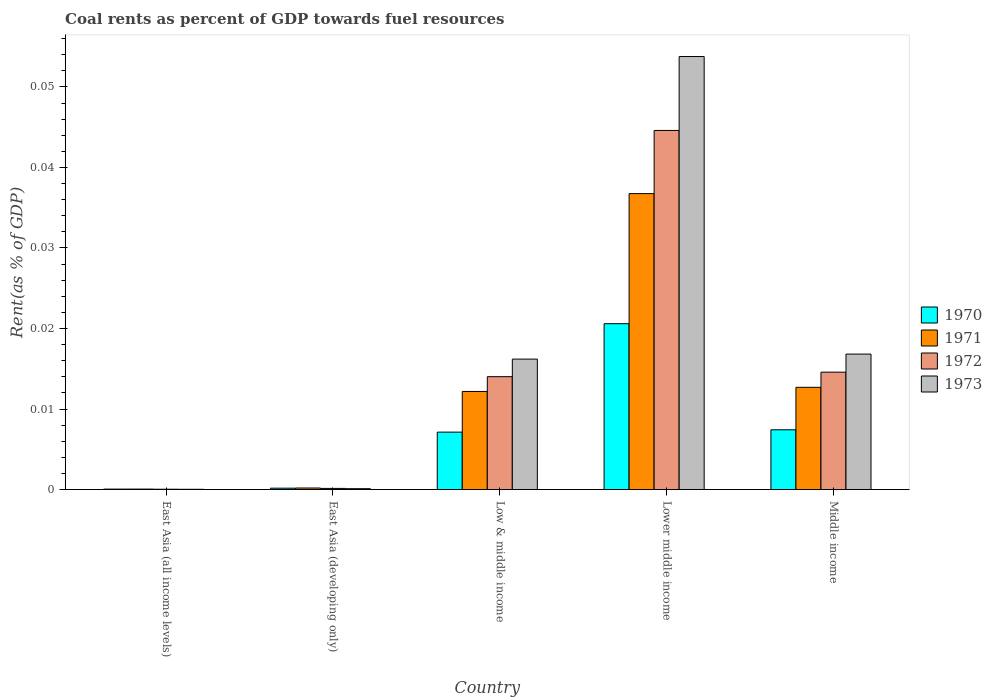How many groups of bars are there?
Your answer should be very brief. 5. Are the number of bars per tick equal to the number of legend labels?
Offer a very short reply. Yes. Are the number of bars on each tick of the X-axis equal?
Your answer should be very brief. Yes. What is the label of the 5th group of bars from the left?
Your answer should be compact. Middle income. What is the coal rent in 1973 in Middle income?
Offer a very short reply. 0.02. Across all countries, what is the maximum coal rent in 1971?
Offer a terse response. 0.04. Across all countries, what is the minimum coal rent in 1971?
Your answer should be very brief. 5.470114168356261e-5. In which country was the coal rent in 1973 maximum?
Your response must be concise. Lower middle income. In which country was the coal rent in 1970 minimum?
Make the answer very short. East Asia (all income levels). What is the total coal rent in 1973 in the graph?
Give a very brief answer. 0.09. What is the difference between the coal rent in 1970 in Lower middle income and that in Middle income?
Offer a very short reply. 0.01. What is the difference between the coal rent in 1973 in Middle income and the coal rent in 1970 in Lower middle income?
Your response must be concise. -0. What is the average coal rent in 1972 per country?
Ensure brevity in your answer.  0.01. What is the difference between the coal rent of/in 1973 and coal rent of/in 1971 in East Asia (all income levels)?
Your response must be concise. -2.828401691496121e-5. What is the ratio of the coal rent in 1971 in East Asia (all income levels) to that in Lower middle income?
Keep it short and to the point. 0. Is the difference between the coal rent in 1973 in East Asia (all income levels) and Lower middle income greater than the difference between the coal rent in 1971 in East Asia (all income levels) and Lower middle income?
Keep it short and to the point. No. What is the difference between the highest and the second highest coal rent in 1972?
Offer a terse response. 0.03. What is the difference between the highest and the lowest coal rent in 1972?
Give a very brief answer. 0.04. In how many countries, is the coal rent in 1973 greater than the average coal rent in 1973 taken over all countries?
Ensure brevity in your answer.  1. Is the sum of the coal rent in 1973 in Lower middle income and Middle income greater than the maximum coal rent in 1972 across all countries?
Offer a terse response. Yes. Is it the case that in every country, the sum of the coal rent in 1970 and coal rent in 1973 is greater than the sum of coal rent in 1972 and coal rent in 1971?
Your answer should be very brief. No. Is it the case that in every country, the sum of the coal rent in 1970 and coal rent in 1972 is greater than the coal rent in 1971?
Ensure brevity in your answer.  Yes. How many bars are there?
Your answer should be compact. 20. Are all the bars in the graph horizontal?
Provide a short and direct response. No. What is the difference between two consecutive major ticks on the Y-axis?
Keep it short and to the point. 0.01. Does the graph contain grids?
Offer a very short reply. No. How many legend labels are there?
Offer a terse response. 4. How are the legend labels stacked?
Make the answer very short. Vertical. What is the title of the graph?
Your answer should be very brief. Coal rents as percent of GDP towards fuel resources. What is the label or title of the X-axis?
Your answer should be compact. Country. What is the label or title of the Y-axis?
Provide a succinct answer. Rent(as % of GDP). What is the Rent(as % of GDP) of 1970 in East Asia (all income levels)?
Make the answer very short. 5.1314079013758e-5. What is the Rent(as % of GDP) in 1971 in East Asia (all income levels)?
Ensure brevity in your answer.  5.470114168356261e-5. What is the Rent(as % of GDP) of 1972 in East Asia (all income levels)?
Offer a terse response. 3.67730514806032e-5. What is the Rent(as % of GDP) of 1973 in East Asia (all income levels)?
Ensure brevity in your answer.  2.64171247686014e-5. What is the Rent(as % of GDP) in 1970 in East Asia (developing only)?
Provide a short and direct response. 0. What is the Rent(as % of GDP) of 1971 in East Asia (developing only)?
Give a very brief answer. 0. What is the Rent(as % of GDP) of 1972 in East Asia (developing only)?
Provide a succinct answer. 0. What is the Rent(as % of GDP) of 1973 in East Asia (developing only)?
Keep it short and to the point. 0. What is the Rent(as % of GDP) in 1970 in Low & middle income?
Offer a very short reply. 0.01. What is the Rent(as % of GDP) of 1971 in Low & middle income?
Make the answer very short. 0.01. What is the Rent(as % of GDP) in 1972 in Low & middle income?
Your answer should be very brief. 0.01. What is the Rent(as % of GDP) in 1973 in Low & middle income?
Ensure brevity in your answer.  0.02. What is the Rent(as % of GDP) of 1970 in Lower middle income?
Your response must be concise. 0.02. What is the Rent(as % of GDP) of 1971 in Lower middle income?
Your response must be concise. 0.04. What is the Rent(as % of GDP) of 1972 in Lower middle income?
Your answer should be compact. 0.04. What is the Rent(as % of GDP) in 1973 in Lower middle income?
Your response must be concise. 0.05. What is the Rent(as % of GDP) of 1970 in Middle income?
Keep it short and to the point. 0.01. What is the Rent(as % of GDP) in 1971 in Middle income?
Your answer should be compact. 0.01. What is the Rent(as % of GDP) of 1972 in Middle income?
Give a very brief answer. 0.01. What is the Rent(as % of GDP) of 1973 in Middle income?
Provide a short and direct response. 0.02. Across all countries, what is the maximum Rent(as % of GDP) of 1970?
Your response must be concise. 0.02. Across all countries, what is the maximum Rent(as % of GDP) of 1971?
Give a very brief answer. 0.04. Across all countries, what is the maximum Rent(as % of GDP) in 1972?
Offer a terse response. 0.04. Across all countries, what is the maximum Rent(as % of GDP) in 1973?
Give a very brief answer. 0.05. Across all countries, what is the minimum Rent(as % of GDP) in 1970?
Offer a terse response. 5.1314079013758e-5. Across all countries, what is the minimum Rent(as % of GDP) of 1971?
Offer a terse response. 5.470114168356261e-5. Across all countries, what is the minimum Rent(as % of GDP) in 1972?
Offer a terse response. 3.67730514806032e-5. Across all countries, what is the minimum Rent(as % of GDP) in 1973?
Give a very brief answer. 2.64171247686014e-5. What is the total Rent(as % of GDP) in 1970 in the graph?
Your response must be concise. 0.04. What is the total Rent(as % of GDP) in 1971 in the graph?
Make the answer very short. 0.06. What is the total Rent(as % of GDP) of 1972 in the graph?
Your response must be concise. 0.07. What is the total Rent(as % of GDP) of 1973 in the graph?
Keep it short and to the point. 0.09. What is the difference between the Rent(as % of GDP) in 1970 in East Asia (all income levels) and that in East Asia (developing only)?
Make the answer very short. -0. What is the difference between the Rent(as % of GDP) in 1971 in East Asia (all income levels) and that in East Asia (developing only)?
Give a very brief answer. -0. What is the difference between the Rent(as % of GDP) of 1972 in East Asia (all income levels) and that in East Asia (developing only)?
Give a very brief answer. -0. What is the difference between the Rent(as % of GDP) of 1973 in East Asia (all income levels) and that in East Asia (developing only)?
Offer a very short reply. -0. What is the difference between the Rent(as % of GDP) in 1970 in East Asia (all income levels) and that in Low & middle income?
Make the answer very short. -0.01. What is the difference between the Rent(as % of GDP) in 1971 in East Asia (all income levels) and that in Low & middle income?
Offer a terse response. -0.01. What is the difference between the Rent(as % of GDP) in 1972 in East Asia (all income levels) and that in Low & middle income?
Make the answer very short. -0.01. What is the difference between the Rent(as % of GDP) of 1973 in East Asia (all income levels) and that in Low & middle income?
Your answer should be very brief. -0.02. What is the difference between the Rent(as % of GDP) of 1970 in East Asia (all income levels) and that in Lower middle income?
Keep it short and to the point. -0.02. What is the difference between the Rent(as % of GDP) of 1971 in East Asia (all income levels) and that in Lower middle income?
Offer a terse response. -0.04. What is the difference between the Rent(as % of GDP) in 1972 in East Asia (all income levels) and that in Lower middle income?
Offer a very short reply. -0.04. What is the difference between the Rent(as % of GDP) of 1973 in East Asia (all income levels) and that in Lower middle income?
Give a very brief answer. -0.05. What is the difference between the Rent(as % of GDP) in 1970 in East Asia (all income levels) and that in Middle income?
Your answer should be very brief. -0.01. What is the difference between the Rent(as % of GDP) of 1971 in East Asia (all income levels) and that in Middle income?
Offer a very short reply. -0.01. What is the difference between the Rent(as % of GDP) of 1972 in East Asia (all income levels) and that in Middle income?
Your answer should be very brief. -0.01. What is the difference between the Rent(as % of GDP) of 1973 in East Asia (all income levels) and that in Middle income?
Give a very brief answer. -0.02. What is the difference between the Rent(as % of GDP) in 1970 in East Asia (developing only) and that in Low & middle income?
Your response must be concise. -0.01. What is the difference between the Rent(as % of GDP) in 1971 in East Asia (developing only) and that in Low & middle income?
Your answer should be very brief. -0.01. What is the difference between the Rent(as % of GDP) in 1972 in East Asia (developing only) and that in Low & middle income?
Your response must be concise. -0.01. What is the difference between the Rent(as % of GDP) of 1973 in East Asia (developing only) and that in Low & middle income?
Keep it short and to the point. -0.02. What is the difference between the Rent(as % of GDP) in 1970 in East Asia (developing only) and that in Lower middle income?
Your response must be concise. -0.02. What is the difference between the Rent(as % of GDP) of 1971 in East Asia (developing only) and that in Lower middle income?
Provide a succinct answer. -0.04. What is the difference between the Rent(as % of GDP) of 1972 in East Asia (developing only) and that in Lower middle income?
Make the answer very short. -0.04. What is the difference between the Rent(as % of GDP) in 1973 in East Asia (developing only) and that in Lower middle income?
Give a very brief answer. -0.05. What is the difference between the Rent(as % of GDP) in 1970 in East Asia (developing only) and that in Middle income?
Provide a succinct answer. -0.01. What is the difference between the Rent(as % of GDP) in 1971 in East Asia (developing only) and that in Middle income?
Your answer should be very brief. -0.01. What is the difference between the Rent(as % of GDP) of 1972 in East Asia (developing only) and that in Middle income?
Give a very brief answer. -0.01. What is the difference between the Rent(as % of GDP) of 1973 in East Asia (developing only) and that in Middle income?
Offer a terse response. -0.02. What is the difference between the Rent(as % of GDP) in 1970 in Low & middle income and that in Lower middle income?
Your answer should be very brief. -0.01. What is the difference between the Rent(as % of GDP) of 1971 in Low & middle income and that in Lower middle income?
Provide a short and direct response. -0.02. What is the difference between the Rent(as % of GDP) in 1972 in Low & middle income and that in Lower middle income?
Your answer should be compact. -0.03. What is the difference between the Rent(as % of GDP) of 1973 in Low & middle income and that in Lower middle income?
Make the answer very short. -0.04. What is the difference between the Rent(as % of GDP) of 1970 in Low & middle income and that in Middle income?
Provide a short and direct response. -0. What is the difference between the Rent(as % of GDP) of 1971 in Low & middle income and that in Middle income?
Your answer should be compact. -0. What is the difference between the Rent(as % of GDP) of 1972 in Low & middle income and that in Middle income?
Your answer should be very brief. -0. What is the difference between the Rent(as % of GDP) of 1973 in Low & middle income and that in Middle income?
Keep it short and to the point. -0. What is the difference between the Rent(as % of GDP) in 1970 in Lower middle income and that in Middle income?
Offer a terse response. 0.01. What is the difference between the Rent(as % of GDP) in 1971 in Lower middle income and that in Middle income?
Provide a short and direct response. 0.02. What is the difference between the Rent(as % of GDP) in 1973 in Lower middle income and that in Middle income?
Give a very brief answer. 0.04. What is the difference between the Rent(as % of GDP) of 1970 in East Asia (all income levels) and the Rent(as % of GDP) of 1971 in East Asia (developing only)?
Give a very brief answer. -0. What is the difference between the Rent(as % of GDP) in 1970 in East Asia (all income levels) and the Rent(as % of GDP) in 1972 in East Asia (developing only)?
Provide a short and direct response. -0. What is the difference between the Rent(as % of GDP) in 1970 in East Asia (all income levels) and the Rent(as % of GDP) in 1973 in East Asia (developing only)?
Offer a terse response. -0. What is the difference between the Rent(as % of GDP) in 1971 in East Asia (all income levels) and the Rent(as % of GDP) in 1972 in East Asia (developing only)?
Ensure brevity in your answer.  -0. What is the difference between the Rent(as % of GDP) of 1972 in East Asia (all income levels) and the Rent(as % of GDP) of 1973 in East Asia (developing only)?
Give a very brief answer. -0. What is the difference between the Rent(as % of GDP) of 1970 in East Asia (all income levels) and the Rent(as % of GDP) of 1971 in Low & middle income?
Your answer should be very brief. -0.01. What is the difference between the Rent(as % of GDP) of 1970 in East Asia (all income levels) and the Rent(as % of GDP) of 1972 in Low & middle income?
Your answer should be very brief. -0.01. What is the difference between the Rent(as % of GDP) in 1970 in East Asia (all income levels) and the Rent(as % of GDP) in 1973 in Low & middle income?
Provide a succinct answer. -0.02. What is the difference between the Rent(as % of GDP) of 1971 in East Asia (all income levels) and the Rent(as % of GDP) of 1972 in Low & middle income?
Your answer should be very brief. -0.01. What is the difference between the Rent(as % of GDP) of 1971 in East Asia (all income levels) and the Rent(as % of GDP) of 1973 in Low & middle income?
Provide a succinct answer. -0.02. What is the difference between the Rent(as % of GDP) of 1972 in East Asia (all income levels) and the Rent(as % of GDP) of 1973 in Low & middle income?
Your response must be concise. -0.02. What is the difference between the Rent(as % of GDP) of 1970 in East Asia (all income levels) and the Rent(as % of GDP) of 1971 in Lower middle income?
Offer a very short reply. -0.04. What is the difference between the Rent(as % of GDP) of 1970 in East Asia (all income levels) and the Rent(as % of GDP) of 1972 in Lower middle income?
Offer a terse response. -0.04. What is the difference between the Rent(as % of GDP) of 1970 in East Asia (all income levels) and the Rent(as % of GDP) of 1973 in Lower middle income?
Provide a succinct answer. -0.05. What is the difference between the Rent(as % of GDP) in 1971 in East Asia (all income levels) and the Rent(as % of GDP) in 1972 in Lower middle income?
Your response must be concise. -0.04. What is the difference between the Rent(as % of GDP) in 1971 in East Asia (all income levels) and the Rent(as % of GDP) in 1973 in Lower middle income?
Keep it short and to the point. -0.05. What is the difference between the Rent(as % of GDP) in 1972 in East Asia (all income levels) and the Rent(as % of GDP) in 1973 in Lower middle income?
Provide a succinct answer. -0.05. What is the difference between the Rent(as % of GDP) in 1970 in East Asia (all income levels) and the Rent(as % of GDP) in 1971 in Middle income?
Offer a terse response. -0.01. What is the difference between the Rent(as % of GDP) in 1970 in East Asia (all income levels) and the Rent(as % of GDP) in 1972 in Middle income?
Ensure brevity in your answer.  -0.01. What is the difference between the Rent(as % of GDP) in 1970 in East Asia (all income levels) and the Rent(as % of GDP) in 1973 in Middle income?
Offer a terse response. -0.02. What is the difference between the Rent(as % of GDP) of 1971 in East Asia (all income levels) and the Rent(as % of GDP) of 1972 in Middle income?
Your answer should be very brief. -0.01. What is the difference between the Rent(as % of GDP) of 1971 in East Asia (all income levels) and the Rent(as % of GDP) of 1973 in Middle income?
Provide a short and direct response. -0.02. What is the difference between the Rent(as % of GDP) of 1972 in East Asia (all income levels) and the Rent(as % of GDP) of 1973 in Middle income?
Offer a very short reply. -0.02. What is the difference between the Rent(as % of GDP) of 1970 in East Asia (developing only) and the Rent(as % of GDP) of 1971 in Low & middle income?
Offer a terse response. -0.01. What is the difference between the Rent(as % of GDP) of 1970 in East Asia (developing only) and the Rent(as % of GDP) of 1972 in Low & middle income?
Your answer should be very brief. -0.01. What is the difference between the Rent(as % of GDP) in 1970 in East Asia (developing only) and the Rent(as % of GDP) in 1973 in Low & middle income?
Provide a short and direct response. -0.02. What is the difference between the Rent(as % of GDP) in 1971 in East Asia (developing only) and the Rent(as % of GDP) in 1972 in Low & middle income?
Your response must be concise. -0.01. What is the difference between the Rent(as % of GDP) of 1971 in East Asia (developing only) and the Rent(as % of GDP) of 1973 in Low & middle income?
Offer a terse response. -0.02. What is the difference between the Rent(as % of GDP) of 1972 in East Asia (developing only) and the Rent(as % of GDP) of 1973 in Low & middle income?
Your response must be concise. -0.02. What is the difference between the Rent(as % of GDP) of 1970 in East Asia (developing only) and the Rent(as % of GDP) of 1971 in Lower middle income?
Offer a very short reply. -0.04. What is the difference between the Rent(as % of GDP) in 1970 in East Asia (developing only) and the Rent(as % of GDP) in 1972 in Lower middle income?
Make the answer very short. -0.04. What is the difference between the Rent(as % of GDP) of 1970 in East Asia (developing only) and the Rent(as % of GDP) of 1973 in Lower middle income?
Ensure brevity in your answer.  -0.05. What is the difference between the Rent(as % of GDP) of 1971 in East Asia (developing only) and the Rent(as % of GDP) of 1972 in Lower middle income?
Ensure brevity in your answer.  -0.04. What is the difference between the Rent(as % of GDP) in 1971 in East Asia (developing only) and the Rent(as % of GDP) in 1973 in Lower middle income?
Your answer should be compact. -0.05. What is the difference between the Rent(as % of GDP) of 1972 in East Asia (developing only) and the Rent(as % of GDP) of 1973 in Lower middle income?
Your answer should be compact. -0.05. What is the difference between the Rent(as % of GDP) in 1970 in East Asia (developing only) and the Rent(as % of GDP) in 1971 in Middle income?
Keep it short and to the point. -0.01. What is the difference between the Rent(as % of GDP) of 1970 in East Asia (developing only) and the Rent(as % of GDP) of 1972 in Middle income?
Keep it short and to the point. -0.01. What is the difference between the Rent(as % of GDP) in 1970 in East Asia (developing only) and the Rent(as % of GDP) in 1973 in Middle income?
Offer a terse response. -0.02. What is the difference between the Rent(as % of GDP) of 1971 in East Asia (developing only) and the Rent(as % of GDP) of 1972 in Middle income?
Your response must be concise. -0.01. What is the difference between the Rent(as % of GDP) of 1971 in East Asia (developing only) and the Rent(as % of GDP) of 1973 in Middle income?
Provide a short and direct response. -0.02. What is the difference between the Rent(as % of GDP) in 1972 in East Asia (developing only) and the Rent(as % of GDP) in 1973 in Middle income?
Your response must be concise. -0.02. What is the difference between the Rent(as % of GDP) in 1970 in Low & middle income and the Rent(as % of GDP) in 1971 in Lower middle income?
Keep it short and to the point. -0.03. What is the difference between the Rent(as % of GDP) of 1970 in Low & middle income and the Rent(as % of GDP) of 1972 in Lower middle income?
Ensure brevity in your answer.  -0.04. What is the difference between the Rent(as % of GDP) in 1970 in Low & middle income and the Rent(as % of GDP) in 1973 in Lower middle income?
Provide a succinct answer. -0.05. What is the difference between the Rent(as % of GDP) in 1971 in Low & middle income and the Rent(as % of GDP) in 1972 in Lower middle income?
Ensure brevity in your answer.  -0.03. What is the difference between the Rent(as % of GDP) of 1971 in Low & middle income and the Rent(as % of GDP) of 1973 in Lower middle income?
Make the answer very short. -0.04. What is the difference between the Rent(as % of GDP) of 1972 in Low & middle income and the Rent(as % of GDP) of 1973 in Lower middle income?
Provide a short and direct response. -0.04. What is the difference between the Rent(as % of GDP) in 1970 in Low & middle income and the Rent(as % of GDP) in 1971 in Middle income?
Provide a short and direct response. -0.01. What is the difference between the Rent(as % of GDP) of 1970 in Low & middle income and the Rent(as % of GDP) of 1972 in Middle income?
Your response must be concise. -0.01. What is the difference between the Rent(as % of GDP) in 1970 in Low & middle income and the Rent(as % of GDP) in 1973 in Middle income?
Provide a succinct answer. -0.01. What is the difference between the Rent(as % of GDP) in 1971 in Low & middle income and the Rent(as % of GDP) in 1972 in Middle income?
Give a very brief answer. -0. What is the difference between the Rent(as % of GDP) in 1971 in Low & middle income and the Rent(as % of GDP) in 1973 in Middle income?
Offer a terse response. -0. What is the difference between the Rent(as % of GDP) of 1972 in Low & middle income and the Rent(as % of GDP) of 1973 in Middle income?
Your answer should be compact. -0. What is the difference between the Rent(as % of GDP) in 1970 in Lower middle income and the Rent(as % of GDP) in 1971 in Middle income?
Keep it short and to the point. 0.01. What is the difference between the Rent(as % of GDP) of 1970 in Lower middle income and the Rent(as % of GDP) of 1972 in Middle income?
Your answer should be compact. 0.01. What is the difference between the Rent(as % of GDP) in 1970 in Lower middle income and the Rent(as % of GDP) in 1973 in Middle income?
Your response must be concise. 0. What is the difference between the Rent(as % of GDP) in 1971 in Lower middle income and the Rent(as % of GDP) in 1972 in Middle income?
Offer a very short reply. 0.02. What is the difference between the Rent(as % of GDP) in 1971 in Lower middle income and the Rent(as % of GDP) in 1973 in Middle income?
Your response must be concise. 0.02. What is the difference between the Rent(as % of GDP) in 1972 in Lower middle income and the Rent(as % of GDP) in 1973 in Middle income?
Offer a very short reply. 0.03. What is the average Rent(as % of GDP) of 1970 per country?
Your answer should be very brief. 0.01. What is the average Rent(as % of GDP) in 1971 per country?
Your response must be concise. 0.01. What is the average Rent(as % of GDP) of 1972 per country?
Offer a very short reply. 0.01. What is the average Rent(as % of GDP) of 1973 per country?
Offer a terse response. 0.02. What is the difference between the Rent(as % of GDP) of 1970 and Rent(as % of GDP) of 1971 in East Asia (all income levels)?
Offer a very short reply. -0. What is the difference between the Rent(as % of GDP) of 1972 and Rent(as % of GDP) of 1973 in East Asia (all income levels)?
Keep it short and to the point. 0. What is the difference between the Rent(as % of GDP) in 1970 and Rent(as % of GDP) in 1971 in East Asia (developing only)?
Your response must be concise. -0. What is the difference between the Rent(as % of GDP) in 1971 and Rent(as % of GDP) in 1973 in East Asia (developing only)?
Your answer should be very brief. 0. What is the difference between the Rent(as % of GDP) in 1970 and Rent(as % of GDP) in 1971 in Low & middle income?
Provide a short and direct response. -0.01. What is the difference between the Rent(as % of GDP) of 1970 and Rent(as % of GDP) of 1972 in Low & middle income?
Provide a succinct answer. -0.01. What is the difference between the Rent(as % of GDP) in 1970 and Rent(as % of GDP) in 1973 in Low & middle income?
Keep it short and to the point. -0.01. What is the difference between the Rent(as % of GDP) of 1971 and Rent(as % of GDP) of 1972 in Low & middle income?
Offer a terse response. -0. What is the difference between the Rent(as % of GDP) of 1971 and Rent(as % of GDP) of 1973 in Low & middle income?
Your answer should be compact. -0. What is the difference between the Rent(as % of GDP) in 1972 and Rent(as % of GDP) in 1973 in Low & middle income?
Provide a succinct answer. -0. What is the difference between the Rent(as % of GDP) of 1970 and Rent(as % of GDP) of 1971 in Lower middle income?
Ensure brevity in your answer.  -0.02. What is the difference between the Rent(as % of GDP) of 1970 and Rent(as % of GDP) of 1972 in Lower middle income?
Your answer should be compact. -0.02. What is the difference between the Rent(as % of GDP) of 1970 and Rent(as % of GDP) of 1973 in Lower middle income?
Offer a very short reply. -0.03. What is the difference between the Rent(as % of GDP) of 1971 and Rent(as % of GDP) of 1972 in Lower middle income?
Ensure brevity in your answer.  -0.01. What is the difference between the Rent(as % of GDP) of 1971 and Rent(as % of GDP) of 1973 in Lower middle income?
Your response must be concise. -0.02. What is the difference between the Rent(as % of GDP) in 1972 and Rent(as % of GDP) in 1973 in Lower middle income?
Your answer should be very brief. -0.01. What is the difference between the Rent(as % of GDP) of 1970 and Rent(as % of GDP) of 1971 in Middle income?
Make the answer very short. -0.01. What is the difference between the Rent(as % of GDP) of 1970 and Rent(as % of GDP) of 1972 in Middle income?
Your answer should be compact. -0.01. What is the difference between the Rent(as % of GDP) of 1970 and Rent(as % of GDP) of 1973 in Middle income?
Offer a very short reply. -0.01. What is the difference between the Rent(as % of GDP) of 1971 and Rent(as % of GDP) of 1972 in Middle income?
Keep it short and to the point. -0. What is the difference between the Rent(as % of GDP) of 1971 and Rent(as % of GDP) of 1973 in Middle income?
Provide a succinct answer. -0. What is the difference between the Rent(as % of GDP) in 1972 and Rent(as % of GDP) in 1973 in Middle income?
Your response must be concise. -0. What is the ratio of the Rent(as % of GDP) of 1970 in East Asia (all income levels) to that in East Asia (developing only)?
Your response must be concise. 0.31. What is the ratio of the Rent(as % of GDP) in 1971 in East Asia (all income levels) to that in East Asia (developing only)?
Offer a terse response. 0.29. What is the ratio of the Rent(as % of GDP) of 1972 in East Asia (all income levels) to that in East Asia (developing only)?
Offer a terse response. 0.27. What is the ratio of the Rent(as % of GDP) in 1973 in East Asia (all income levels) to that in East Asia (developing only)?
Offer a terse response. 0.26. What is the ratio of the Rent(as % of GDP) in 1970 in East Asia (all income levels) to that in Low & middle income?
Your response must be concise. 0.01. What is the ratio of the Rent(as % of GDP) of 1971 in East Asia (all income levels) to that in Low & middle income?
Your response must be concise. 0. What is the ratio of the Rent(as % of GDP) in 1972 in East Asia (all income levels) to that in Low & middle income?
Give a very brief answer. 0. What is the ratio of the Rent(as % of GDP) of 1973 in East Asia (all income levels) to that in Low & middle income?
Provide a succinct answer. 0. What is the ratio of the Rent(as % of GDP) in 1970 in East Asia (all income levels) to that in Lower middle income?
Keep it short and to the point. 0. What is the ratio of the Rent(as % of GDP) of 1971 in East Asia (all income levels) to that in Lower middle income?
Ensure brevity in your answer.  0. What is the ratio of the Rent(as % of GDP) in 1972 in East Asia (all income levels) to that in Lower middle income?
Ensure brevity in your answer.  0. What is the ratio of the Rent(as % of GDP) in 1970 in East Asia (all income levels) to that in Middle income?
Provide a succinct answer. 0.01. What is the ratio of the Rent(as % of GDP) of 1971 in East Asia (all income levels) to that in Middle income?
Offer a terse response. 0. What is the ratio of the Rent(as % of GDP) in 1972 in East Asia (all income levels) to that in Middle income?
Make the answer very short. 0. What is the ratio of the Rent(as % of GDP) in 1973 in East Asia (all income levels) to that in Middle income?
Provide a succinct answer. 0. What is the ratio of the Rent(as % of GDP) of 1970 in East Asia (developing only) to that in Low & middle income?
Your answer should be compact. 0.02. What is the ratio of the Rent(as % of GDP) of 1971 in East Asia (developing only) to that in Low & middle income?
Ensure brevity in your answer.  0.02. What is the ratio of the Rent(as % of GDP) in 1972 in East Asia (developing only) to that in Low & middle income?
Keep it short and to the point. 0.01. What is the ratio of the Rent(as % of GDP) in 1973 in East Asia (developing only) to that in Low & middle income?
Keep it short and to the point. 0.01. What is the ratio of the Rent(as % of GDP) of 1970 in East Asia (developing only) to that in Lower middle income?
Offer a terse response. 0.01. What is the ratio of the Rent(as % of GDP) in 1971 in East Asia (developing only) to that in Lower middle income?
Offer a terse response. 0.01. What is the ratio of the Rent(as % of GDP) of 1972 in East Asia (developing only) to that in Lower middle income?
Offer a terse response. 0. What is the ratio of the Rent(as % of GDP) in 1973 in East Asia (developing only) to that in Lower middle income?
Give a very brief answer. 0. What is the ratio of the Rent(as % of GDP) of 1970 in East Asia (developing only) to that in Middle income?
Make the answer very short. 0.02. What is the ratio of the Rent(as % of GDP) of 1971 in East Asia (developing only) to that in Middle income?
Provide a succinct answer. 0.01. What is the ratio of the Rent(as % of GDP) in 1972 in East Asia (developing only) to that in Middle income?
Offer a very short reply. 0.01. What is the ratio of the Rent(as % of GDP) of 1973 in East Asia (developing only) to that in Middle income?
Your answer should be very brief. 0.01. What is the ratio of the Rent(as % of GDP) of 1970 in Low & middle income to that in Lower middle income?
Your answer should be very brief. 0.35. What is the ratio of the Rent(as % of GDP) of 1971 in Low & middle income to that in Lower middle income?
Provide a short and direct response. 0.33. What is the ratio of the Rent(as % of GDP) in 1972 in Low & middle income to that in Lower middle income?
Your answer should be compact. 0.31. What is the ratio of the Rent(as % of GDP) in 1973 in Low & middle income to that in Lower middle income?
Make the answer very short. 0.3. What is the ratio of the Rent(as % of GDP) of 1970 in Low & middle income to that in Middle income?
Provide a short and direct response. 0.96. What is the ratio of the Rent(as % of GDP) in 1971 in Low & middle income to that in Middle income?
Make the answer very short. 0.96. What is the ratio of the Rent(as % of GDP) in 1972 in Low & middle income to that in Middle income?
Your answer should be compact. 0.96. What is the ratio of the Rent(as % of GDP) of 1973 in Low & middle income to that in Middle income?
Make the answer very short. 0.96. What is the ratio of the Rent(as % of GDP) in 1970 in Lower middle income to that in Middle income?
Offer a terse response. 2.78. What is the ratio of the Rent(as % of GDP) of 1971 in Lower middle income to that in Middle income?
Your answer should be compact. 2.9. What is the ratio of the Rent(as % of GDP) of 1972 in Lower middle income to that in Middle income?
Keep it short and to the point. 3.06. What is the ratio of the Rent(as % of GDP) of 1973 in Lower middle income to that in Middle income?
Ensure brevity in your answer.  3.2. What is the difference between the highest and the second highest Rent(as % of GDP) in 1970?
Offer a terse response. 0.01. What is the difference between the highest and the second highest Rent(as % of GDP) of 1971?
Ensure brevity in your answer.  0.02. What is the difference between the highest and the second highest Rent(as % of GDP) in 1972?
Offer a terse response. 0.03. What is the difference between the highest and the second highest Rent(as % of GDP) in 1973?
Give a very brief answer. 0.04. What is the difference between the highest and the lowest Rent(as % of GDP) in 1970?
Ensure brevity in your answer.  0.02. What is the difference between the highest and the lowest Rent(as % of GDP) in 1971?
Offer a terse response. 0.04. What is the difference between the highest and the lowest Rent(as % of GDP) in 1972?
Give a very brief answer. 0.04. What is the difference between the highest and the lowest Rent(as % of GDP) of 1973?
Provide a short and direct response. 0.05. 